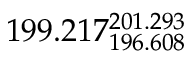Convert formula to latex. <formula><loc_0><loc_0><loc_500><loc_500>1 9 9 . 2 1 7 _ { 1 9 6 . 6 0 8 } ^ { 2 0 1 . 2 9 3 }</formula> 